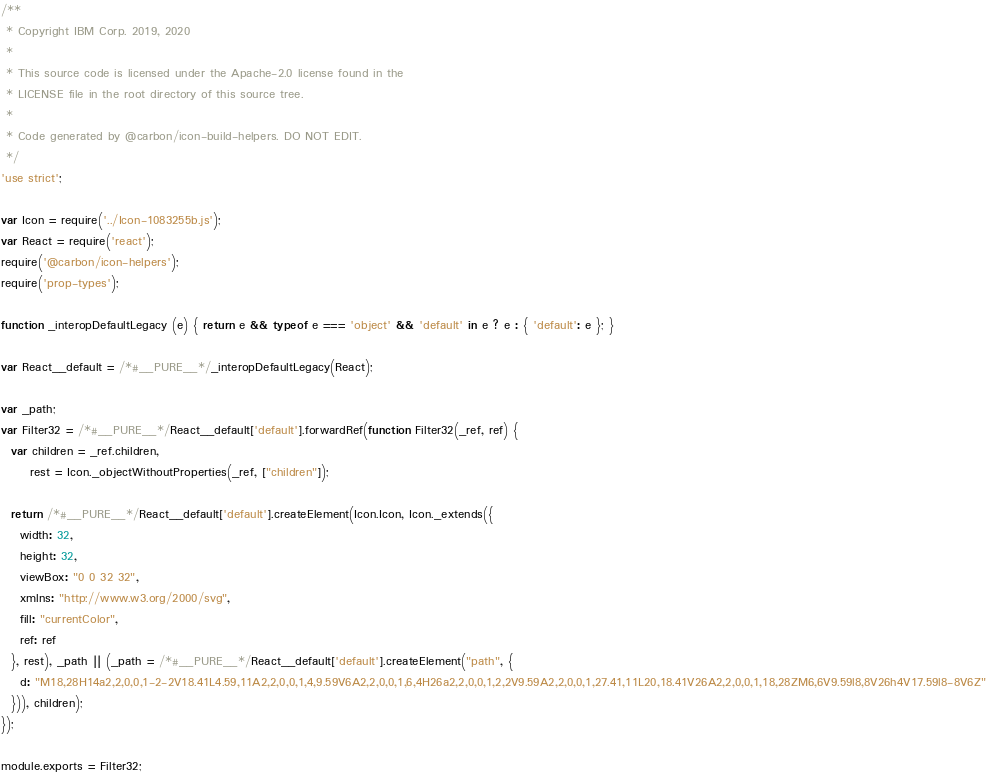Convert code to text. <code><loc_0><loc_0><loc_500><loc_500><_JavaScript_>/**
 * Copyright IBM Corp. 2019, 2020
 *
 * This source code is licensed under the Apache-2.0 license found in the
 * LICENSE file in the root directory of this source tree.
 *
 * Code generated by @carbon/icon-build-helpers. DO NOT EDIT.
 */
'use strict';

var Icon = require('../Icon-1083255b.js');
var React = require('react');
require('@carbon/icon-helpers');
require('prop-types');

function _interopDefaultLegacy (e) { return e && typeof e === 'object' && 'default' in e ? e : { 'default': e }; }

var React__default = /*#__PURE__*/_interopDefaultLegacy(React);

var _path;
var Filter32 = /*#__PURE__*/React__default['default'].forwardRef(function Filter32(_ref, ref) {
  var children = _ref.children,
      rest = Icon._objectWithoutProperties(_ref, ["children"]);

  return /*#__PURE__*/React__default['default'].createElement(Icon.Icon, Icon._extends({
    width: 32,
    height: 32,
    viewBox: "0 0 32 32",
    xmlns: "http://www.w3.org/2000/svg",
    fill: "currentColor",
    ref: ref
  }, rest), _path || (_path = /*#__PURE__*/React__default['default'].createElement("path", {
    d: "M18,28H14a2,2,0,0,1-2-2V18.41L4.59,11A2,2,0,0,1,4,9.59V6A2,2,0,0,1,6,4H26a2,2,0,0,1,2,2V9.59A2,2,0,0,1,27.41,11L20,18.41V26A2,2,0,0,1,18,28ZM6,6V9.59l8,8V26h4V17.59l8-8V6Z"
  })), children);
});

module.exports = Filter32;
</code> 